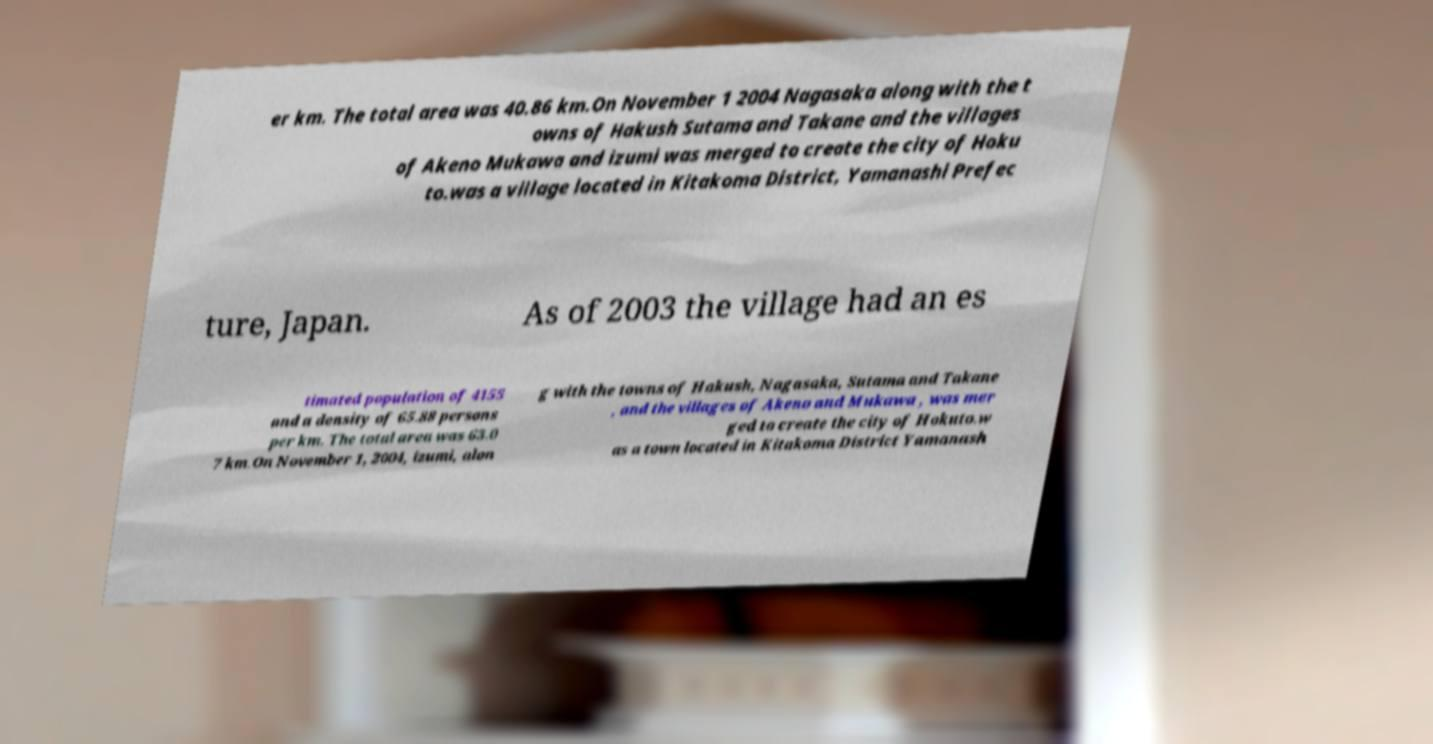Please read and relay the text visible in this image. What does it say? er km. The total area was 40.86 km.On November 1 2004 Nagasaka along with the t owns of Hakush Sutama and Takane and the villages of Akeno Mukawa and izumi was merged to create the city of Hoku to.was a village located in Kitakoma District, Yamanashi Prefec ture, Japan. As of 2003 the village had an es timated population of 4155 and a density of 65.88 persons per km. The total area was 63.0 7 km.On November 1, 2004, izumi, alon g with the towns of Hakush, Nagasaka, Sutama and Takane , and the villages of Akeno and Mukawa , was mer ged to create the city of Hokuto.w as a town located in Kitakoma District Yamanash 